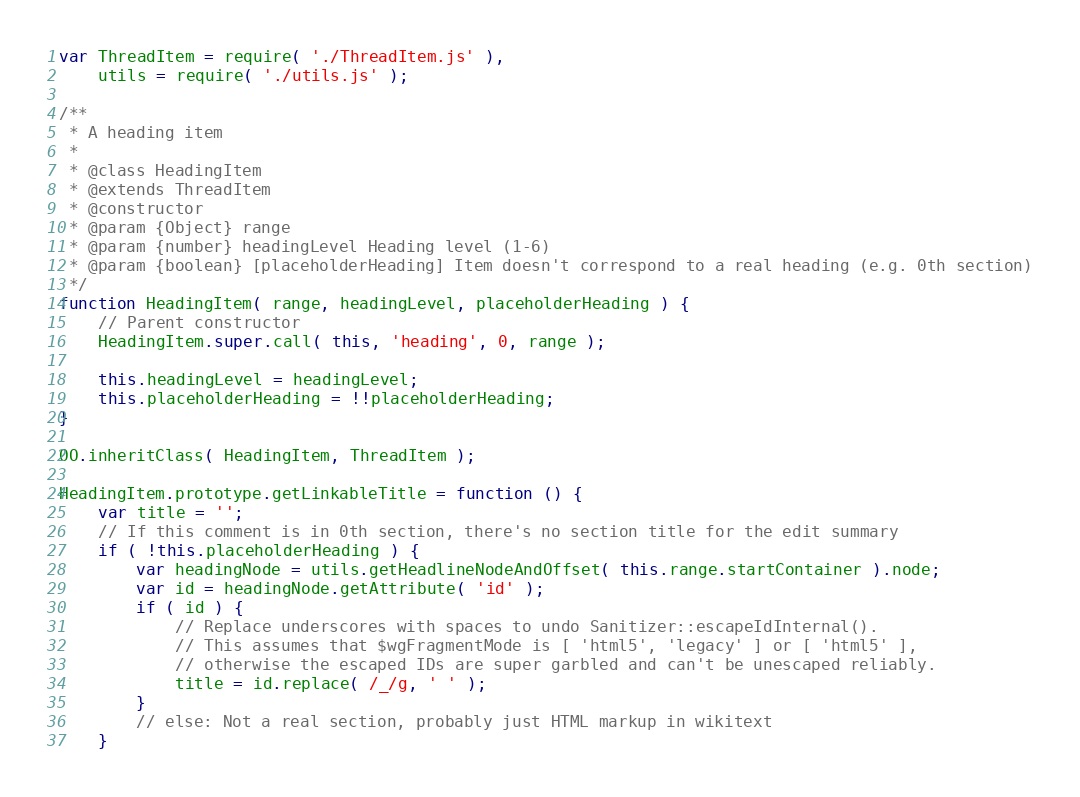Convert code to text. <code><loc_0><loc_0><loc_500><loc_500><_JavaScript_>var ThreadItem = require( './ThreadItem.js' ),
	utils = require( './utils.js' );

/**
 * A heading item
 *
 * @class HeadingItem
 * @extends ThreadItem
 * @constructor
 * @param {Object} range
 * @param {number} headingLevel Heading level (1-6)
 * @param {boolean} [placeholderHeading] Item doesn't correspond to a real heading (e.g. 0th section)
 */
function HeadingItem( range, headingLevel, placeholderHeading ) {
	// Parent constructor
	HeadingItem.super.call( this, 'heading', 0, range );

	this.headingLevel = headingLevel;
	this.placeholderHeading = !!placeholderHeading;
}

OO.inheritClass( HeadingItem, ThreadItem );

HeadingItem.prototype.getLinkableTitle = function () {
	var title = '';
	// If this comment is in 0th section, there's no section title for the edit summary
	if ( !this.placeholderHeading ) {
		var headingNode = utils.getHeadlineNodeAndOffset( this.range.startContainer ).node;
		var id = headingNode.getAttribute( 'id' );
		if ( id ) {
			// Replace underscores with spaces to undo Sanitizer::escapeIdInternal().
			// This assumes that $wgFragmentMode is [ 'html5', 'legacy' ] or [ 'html5' ],
			// otherwise the escaped IDs are super garbled and can't be unescaped reliably.
			title = id.replace( /_/g, ' ' );
		}
		// else: Not a real section, probably just HTML markup in wikitext
	}</code> 